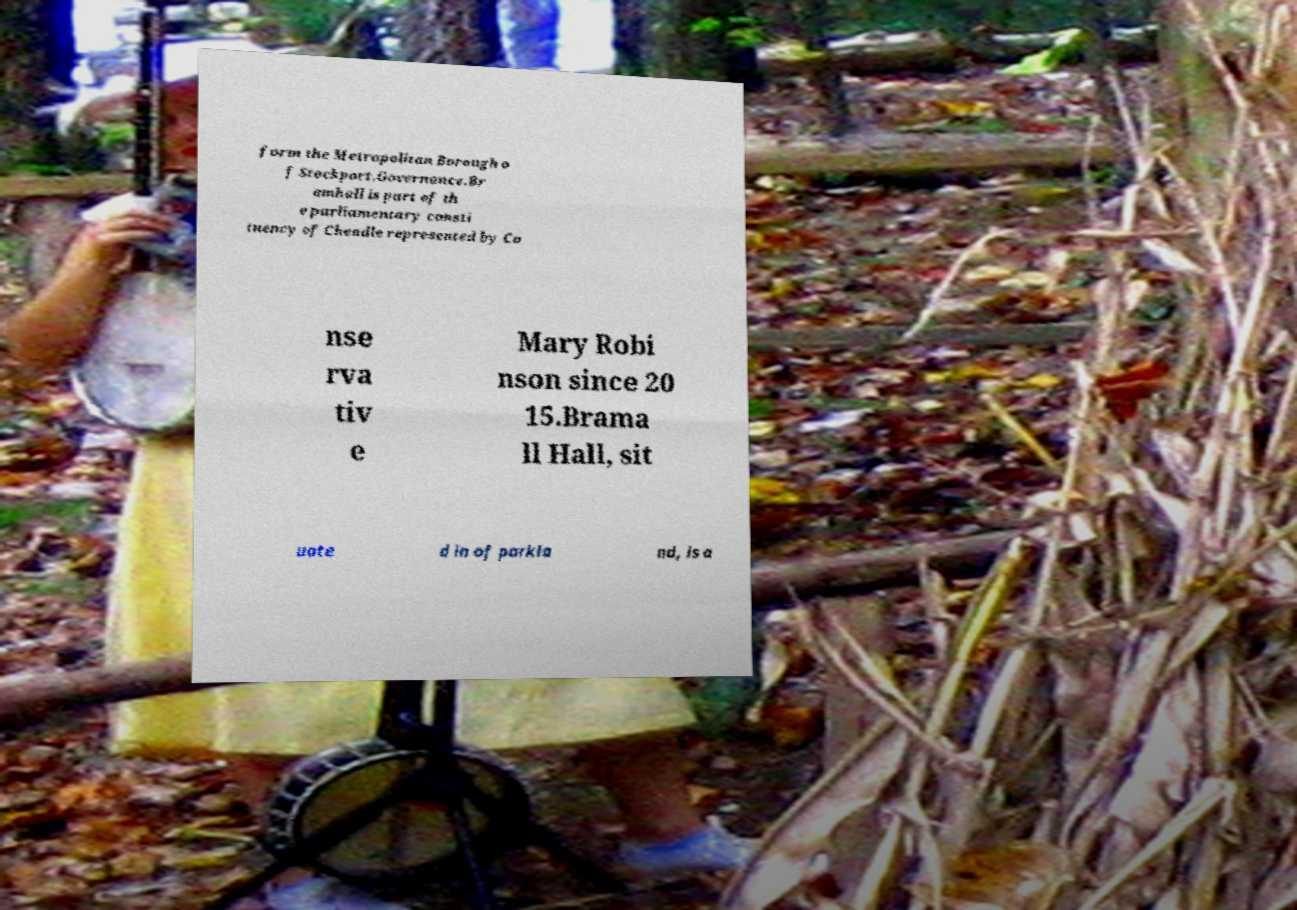I need the written content from this picture converted into text. Can you do that? form the Metropolitan Borough o f Stockport.Governance.Br amhall is part of th e parliamentary consti tuency of Cheadle represented by Co nse rva tiv e Mary Robi nson since 20 15.Brama ll Hall, sit uate d in of parkla nd, is a 